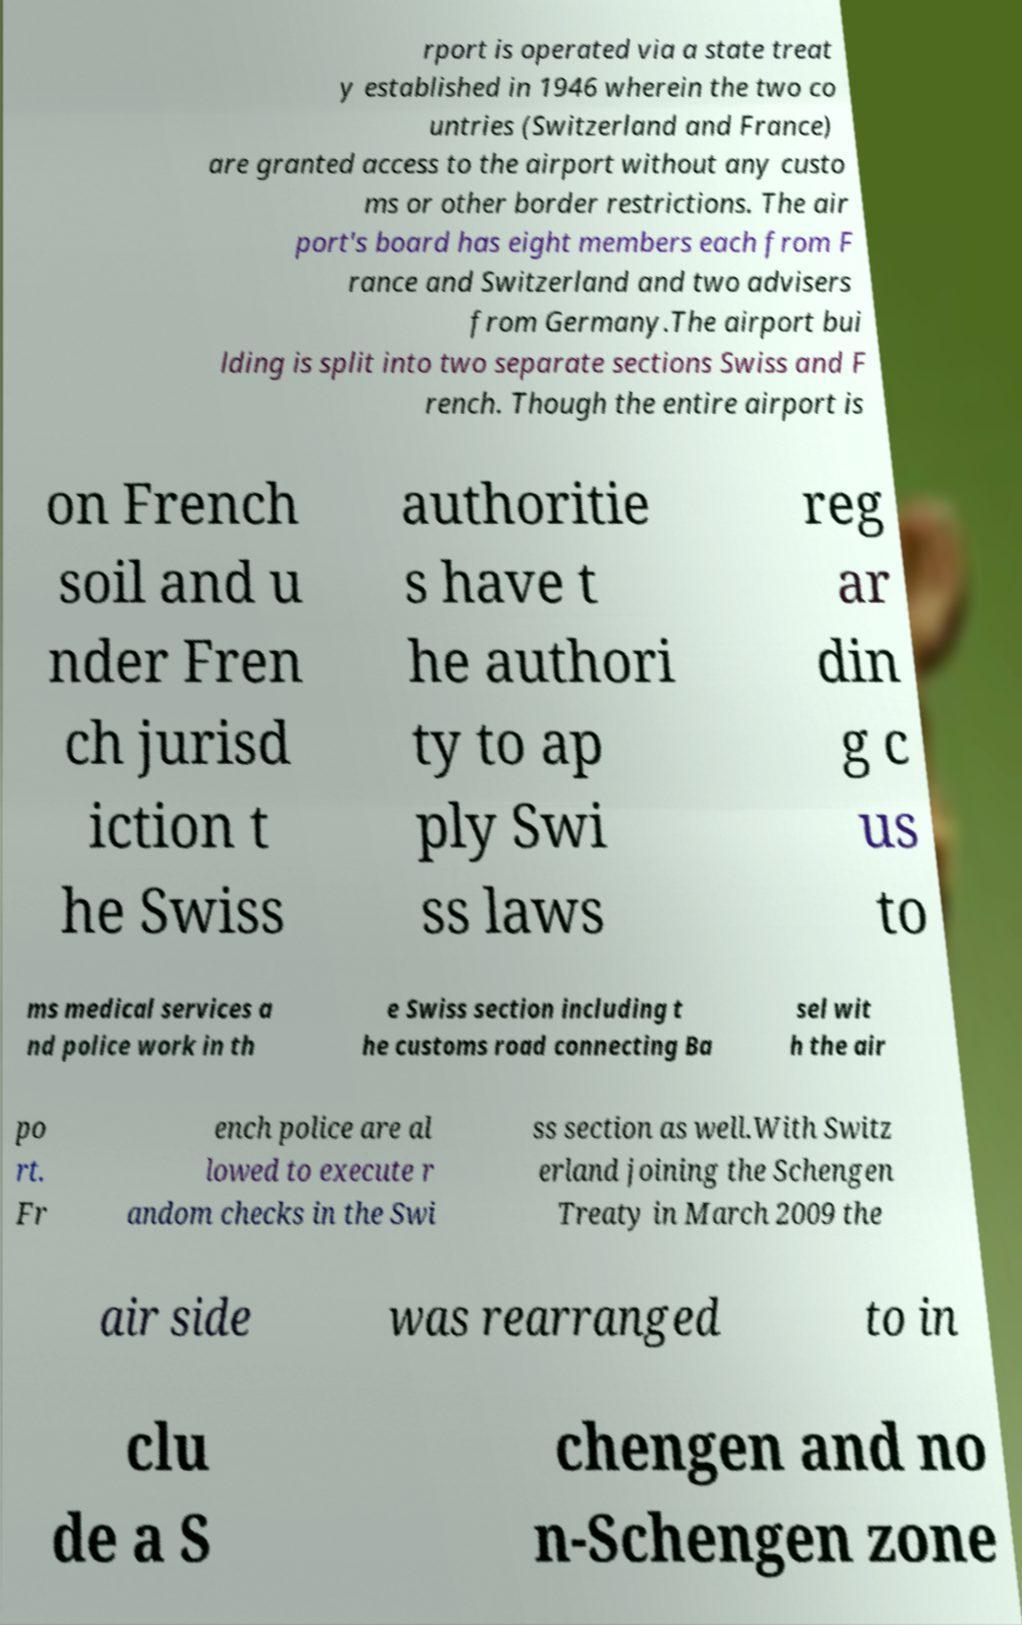What messages or text are displayed in this image? I need them in a readable, typed format. rport is operated via a state treat y established in 1946 wherein the two co untries (Switzerland and France) are granted access to the airport without any custo ms or other border restrictions. The air port's board has eight members each from F rance and Switzerland and two advisers from Germany.The airport bui lding is split into two separate sections Swiss and F rench. Though the entire airport is on French soil and u nder Fren ch jurisd iction t he Swiss authoritie s have t he authori ty to ap ply Swi ss laws reg ar din g c us to ms medical services a nd police work in th e Swiss section including t he customs road connecting Ba sel wit h the air po rt. Fr ench police are al lowed to execute r andom checks in the Swi ss section as well.With Switz erland joining the Schengen Treaty in March 2009 the air side was rearranged to in clu de a S chengen and no n-Schengen zone 